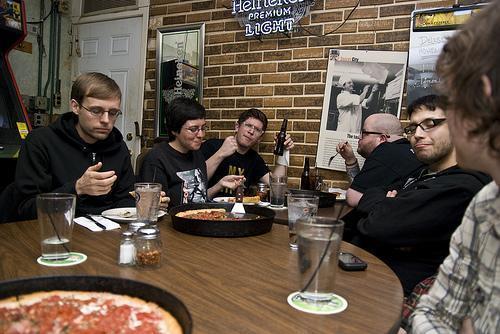How many people are bald?
Give a very brief answer. 1. How many of the drinks are in bottles?
Give a very brief answer. 2. 